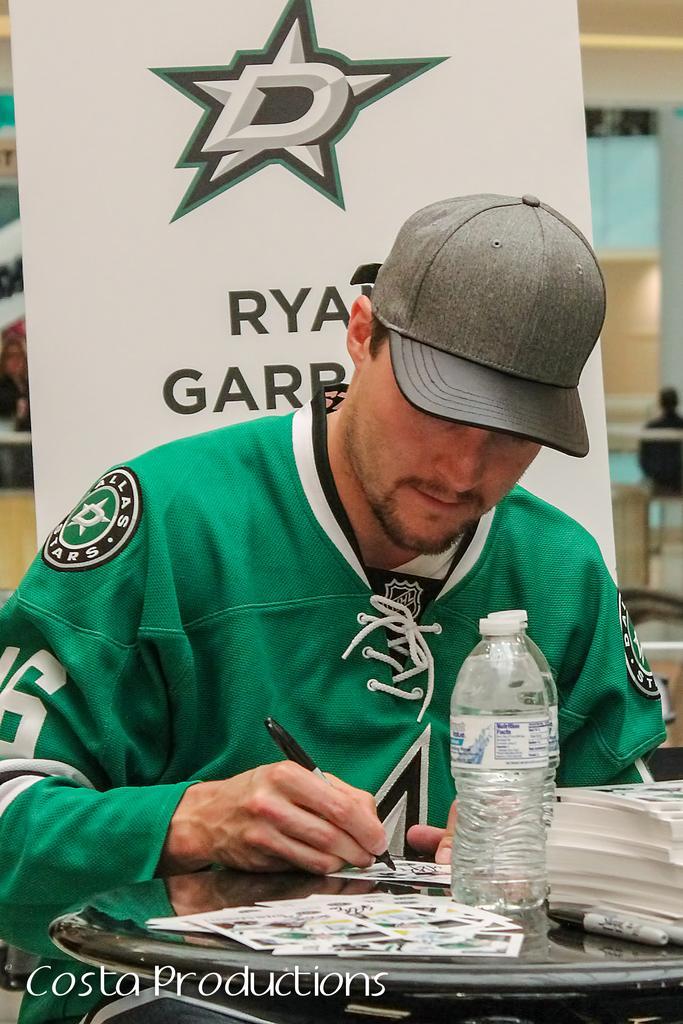Could you give a brief overview of what you see in this image? In this picture we can see a man who is sitting on the chair. This is table. On the table there are some cards, bottle, and books. He wear a cap, and he is holding a pen with his hand. 